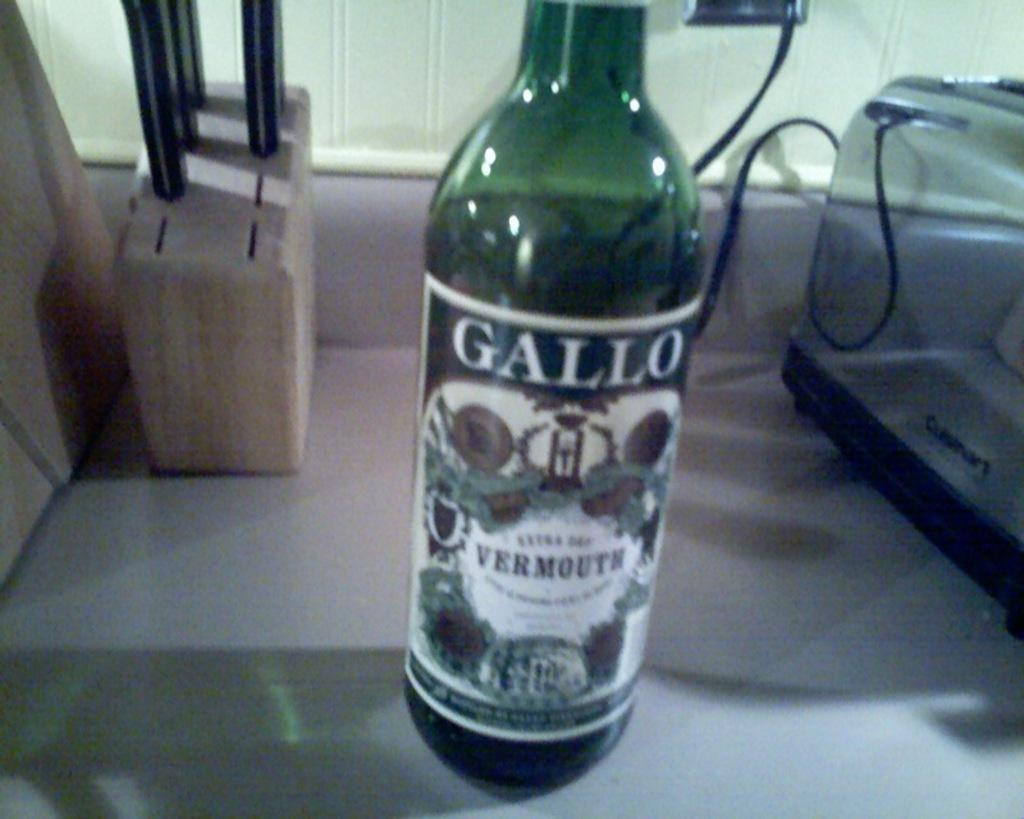<image>
Share a concise interpretation of the image provided. A bottle of Gallo sits between a knife block and a toaster. 